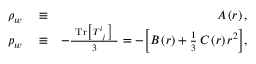<formula> <loc_0><loc_0><loc_500><loc_500>\begin{array} { r l r } { \rho _ { w } } & \equiv } & { A \left ( r \right ) , } \\ { p _ { w } } & \equiv } & { - \frac { T r \left [ \, T _ { \, j } ^ { i } \, \right ] } { 3 } = - \left [ B \left ( r \right ) + \frac { 1 } { 3 } \, C \left ( r \right ) r ^ { 2 } \right ] , } \end{array}</formula> 